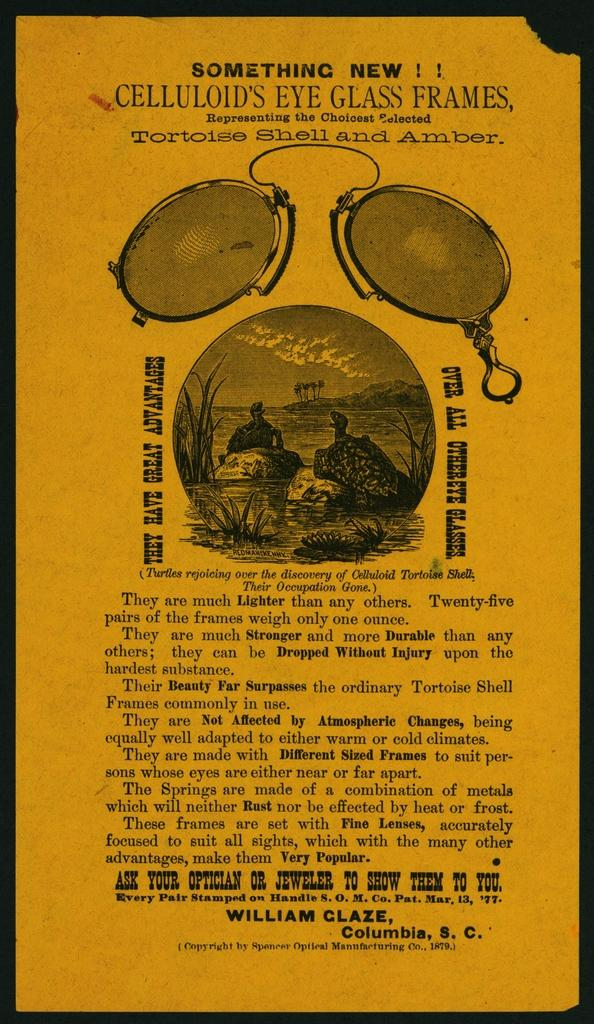Provide a one-sentence caption for the provided image. Poster that says "Something New" on top showing two tortoises having a conversation. 